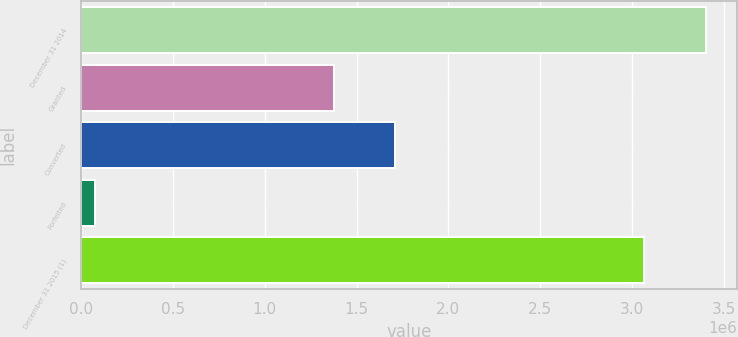Convert chart. <chart><loc_0><loc_0><loc_500><loc_500><bar_chart><fcel>December 31 2014<fcel>Granted<fcel>Converted<fcel>Forfeited<fcel>December 31 2015 (1)<nl><fcel>3.40191e+06<fcel>1.37726e+06<fcel>1.71022e+06<fcel>72357<fcel>3.06774e+06<nl></chart> 